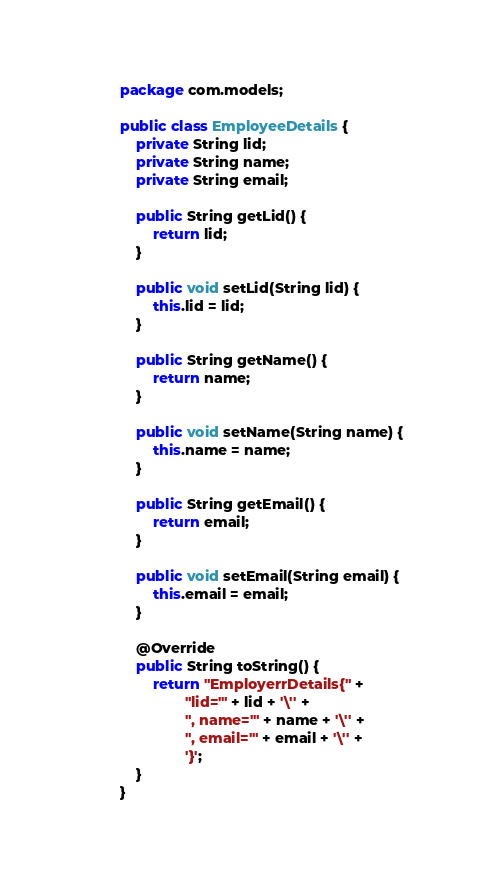<code> <loc_0><loc_0><loc_500><loc_500><_Java_>package com.models;

public class EmployeeDetails {
    private String lid;
    private String name;
    private String email;

    public String getLid() {
        return lid;
    }

    public void setLid(String lid) {
        this.lid = lid;
    }

    public String getName() {
        return name;
    }

    public void setName(String name) {
        this.name = name;
    }

    public String getEmail() {
        return email;
    }

    public void setEmail(String email) {
        this.email = email;
    }

    @Override
    public String toString() {
        return "EmployerrDetails{" +
                "lid='" + lid + '\'' +
                ", name='" + name + '\'' +
                ", email='" + email + '\'' +
                '}';
    }
}
</code> 